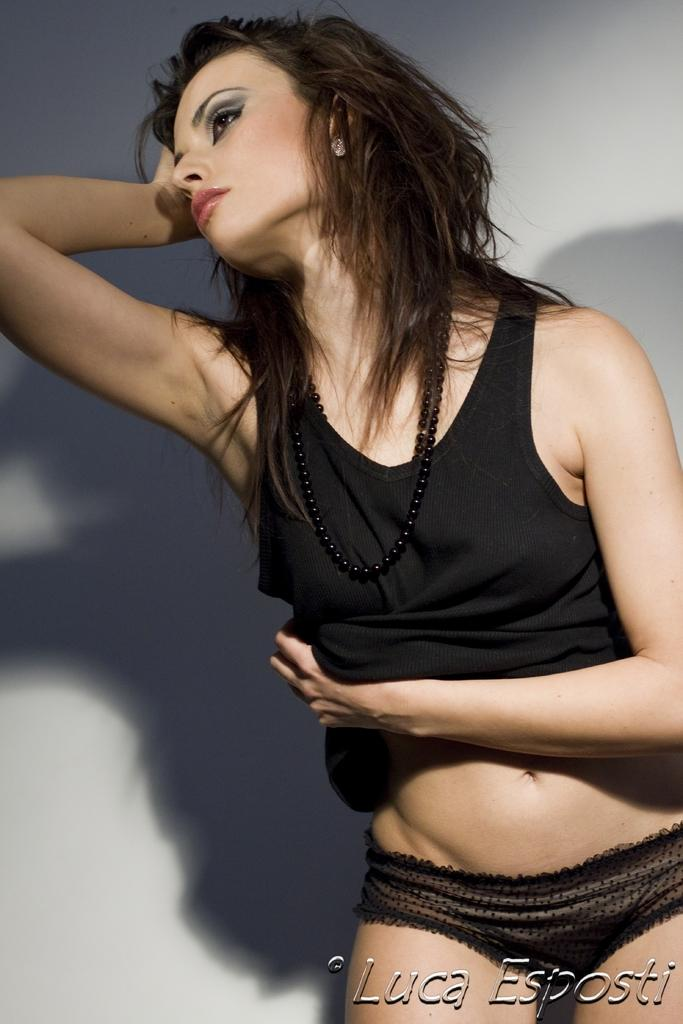What is the main subject of the image? There is a lady standing in the image. What can be found at the bottom of the image? There is text written at the bottom of the image. What color is the background of the image? The background of the image is white. What type of scissors is the lady using in the image? There are no scissors present in the image; the lady is simply standing. What is the account number of the lady in the image? There is no account number mentioned or visible in the image. 